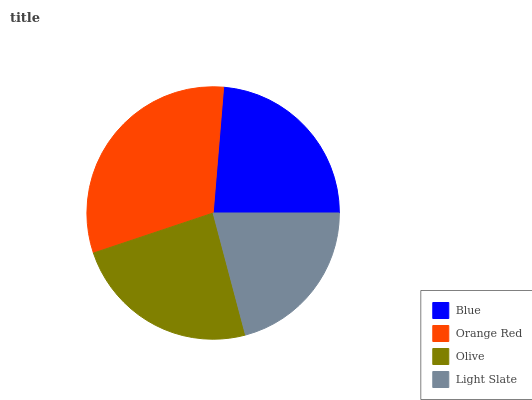Is Light Slate the minimum?
Answer yes or no. Yes. Is Orange Red the maximum?
Answer yes or no. Yes. Is Olive the minimum?
Answer yes or no. No. Is Olive the maximum?
Answer yes or no. No. Is Orange Red greater than Olive?
Answer yes or no. Yes. Is Olive less than Orange Red?
Answer yes or no. Yes. Is Olive greater than Orange Red?
Answer yes or no. No. Is Orange Red less than Olive?
Answer yes or no. No. Is Olive the high median?
Answer yes or no. Yes. Is Blue the low median?
Answer yes or no. Yes. Is Orange Red the high median?
Answer yes or no. No. Is Light Slate the low median?
Answer yes or no. No. 